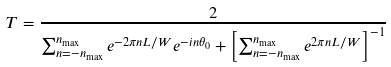Convert formula to latex. <formula><loc_0><loc_0><loc_500><loc_500>T = \frac { 2 } { \sum _ { n = - n _ { \max } } ^ { n _ { \max } } e ^ { - 2 \pi n L / W } e ^ { - i n \theta _ { 0 } } + \left [ \sum _ { n = - n _ { \max } } ^ { n _ { \max } } e ^ { 2 \pi n L / W } \right ] ^ { - 1 } }</formula> 